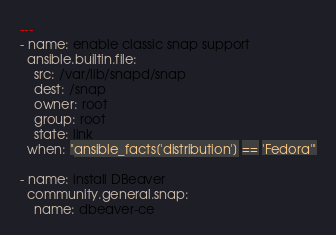Convert code to text. <code><loc_0><loc_0><loc_500><loc_500><_YAML_>---
- name: enable classic snap support
  ansible.builtin.file:
    src: /var/lib/snapd/snap
    dest: /snap
    owner: root
    group: root
    state: link
  when: "ansible_facts['distribution'] == 'Fedora'"

- name: install DBeaver
  community.general.snap:
    name: dbeaver-ce
</code> 